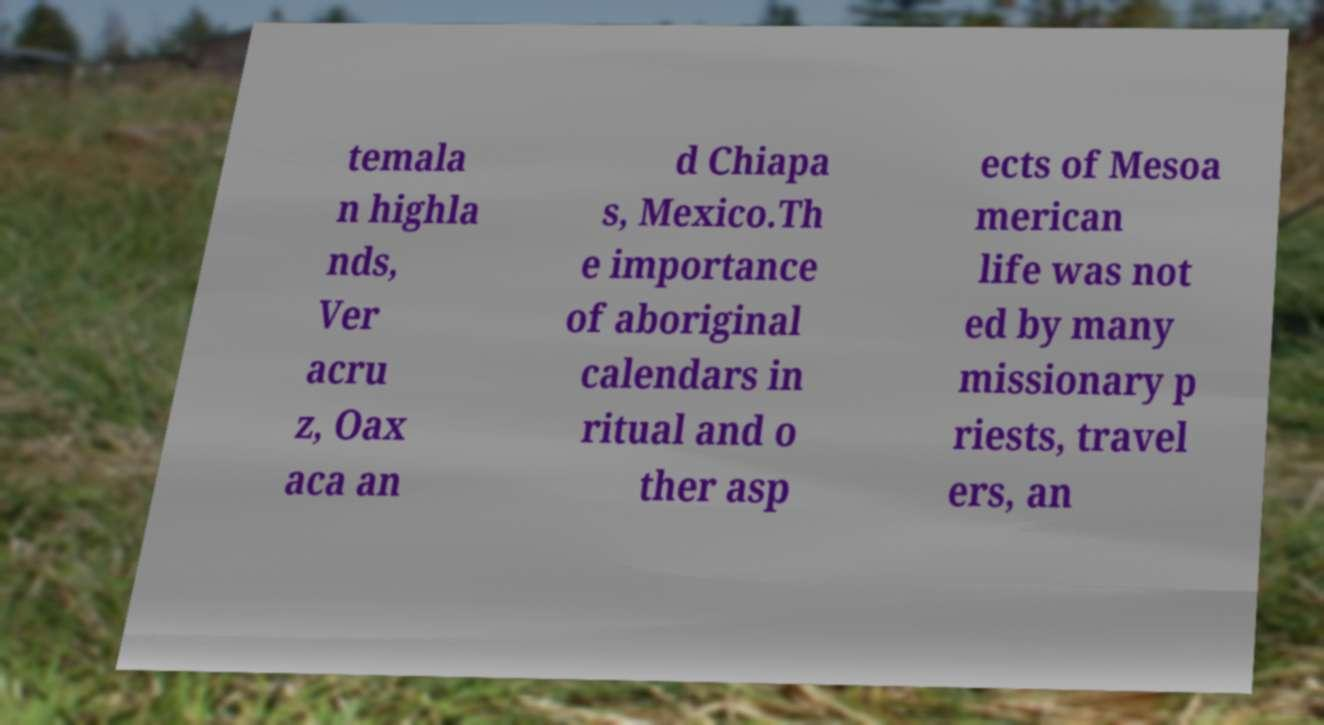Can you accurately transcribe the text from the provided image for me? temala n highla nds, Ver acru z, Oax aca an d Chiapa s, Mexico.Th e importance of aboriginal calendars in ritual and o ther asp ects of Mesoa merican life was not ed by many missionary p riests, travel ers, an 